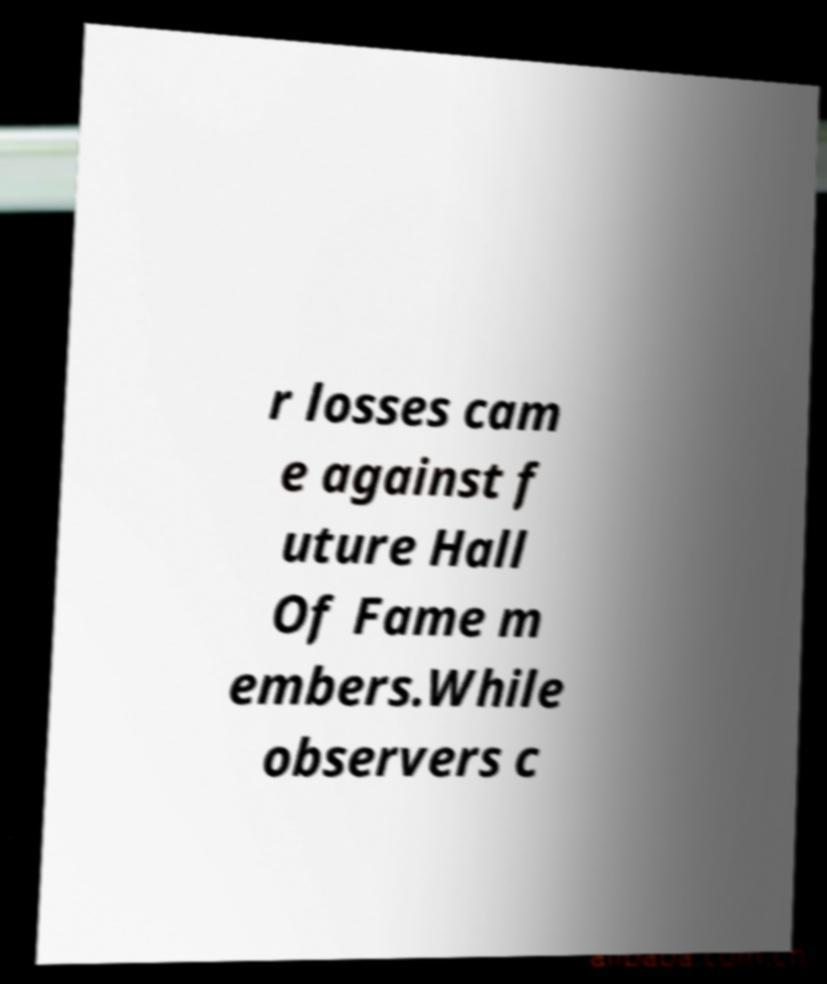Please identify and transcribe the text found in this image. r losses cam e against f uture Hall Of Fame m embers.While observers c 